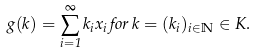Convert formula to latex. <formula><loc_0><loc_0><loc_500><loc_500>g ( k ) = \sum _ { i = 1 } ^ { \infty } k _ { i } x _ { i } \, f o r \, k = ( k _ { i } ) _ { i \in \mathbb { N } } \in K .</formula> 